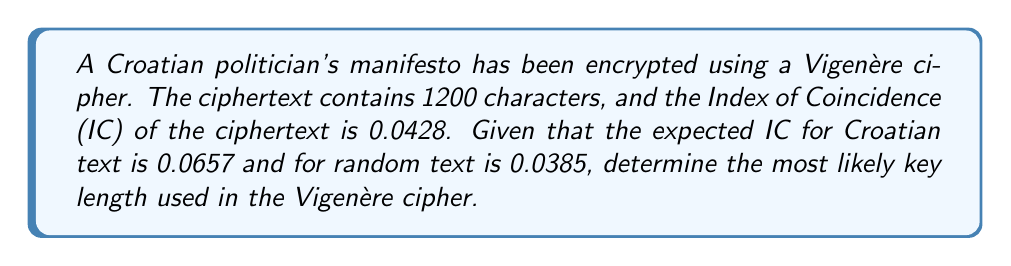Can you answer this question? To find the key length of a Vigenère cipher, we can use the Index of Coincidence (IC) method. Let's follow these steps:

1. We know:
   - IC of ciphertext: $IC_{obs} = 0.0428$
   - IC of Croatian language: $IC_{lang} = 0.0657$
   - IC of random text: $IC_{rand} = 0.0385$

2. The formula for the expected IC of a Vigenère cipher with key length $L$ is:

   $$IC_{exp} = \frac{1}{L} \cdot IC_{lang} + \frac{L-1}{L} \cdot IC_{rand}$$

3. We want to find $L$ such that $IC_{exp}$ is close to $IC_{obs}$. Let's rearrange the formula:

   $$IC_{obs} = \frac{1}{L} \cdot IC_{lang} + \frac{L-1}{L} \cdot IC_{rand}$$

4. Solving for $L$:

   $$L = \frac{IC_{lang} - IC_{rand}}{IC_{obs} - IC_{rand}}$$

5. Substituting the values:

   $$L = \frac{0.0657 - 0.0385}{0.0428 - 0.0385} = \frac{0.0272}{0.0043} = 6.3256$$

6. Since the key length must be an integer, we round to the nearest whole number:

   $$L \approx 6$$

Therefore, the most likely key length used in this Vigenère cipher is 6 characters.
Answer: 6 